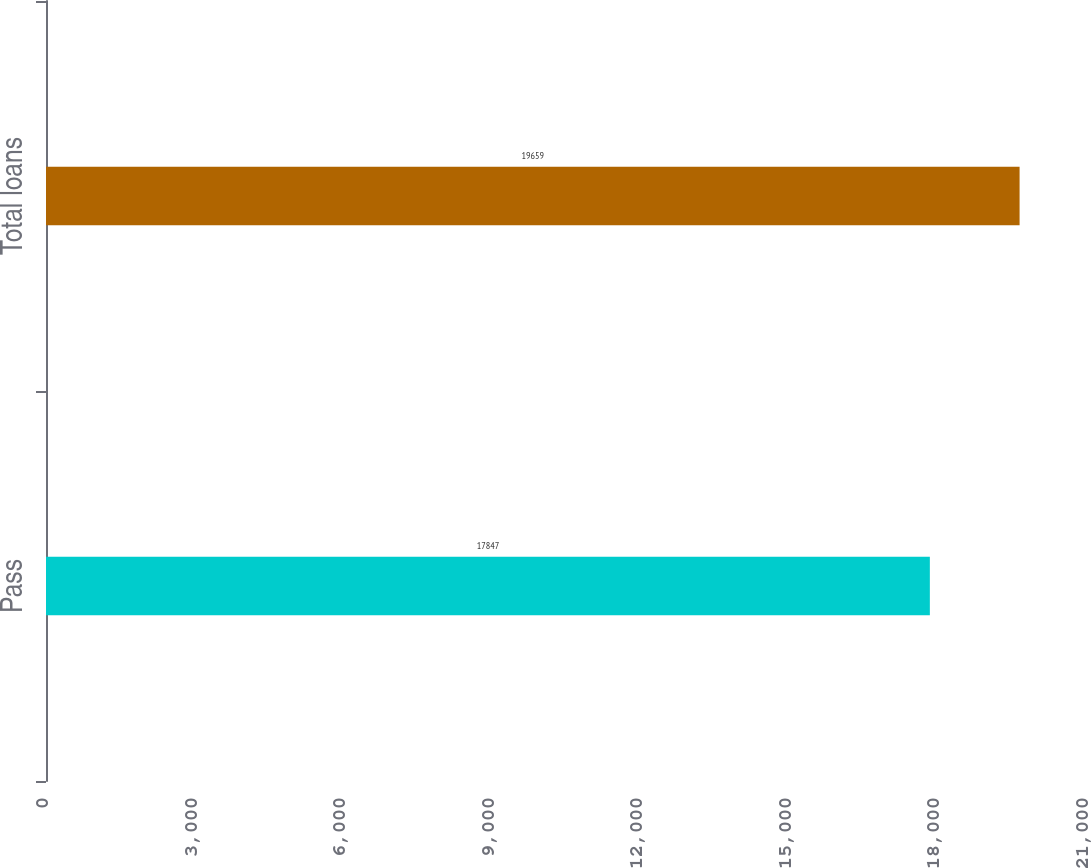<chart> <loc_0><loc_0><loc_500><loc_500><bar_chart><fcel>Pass<fcel>Total loans<nl><fcel>17847<fcel>19659<nl></chart> 